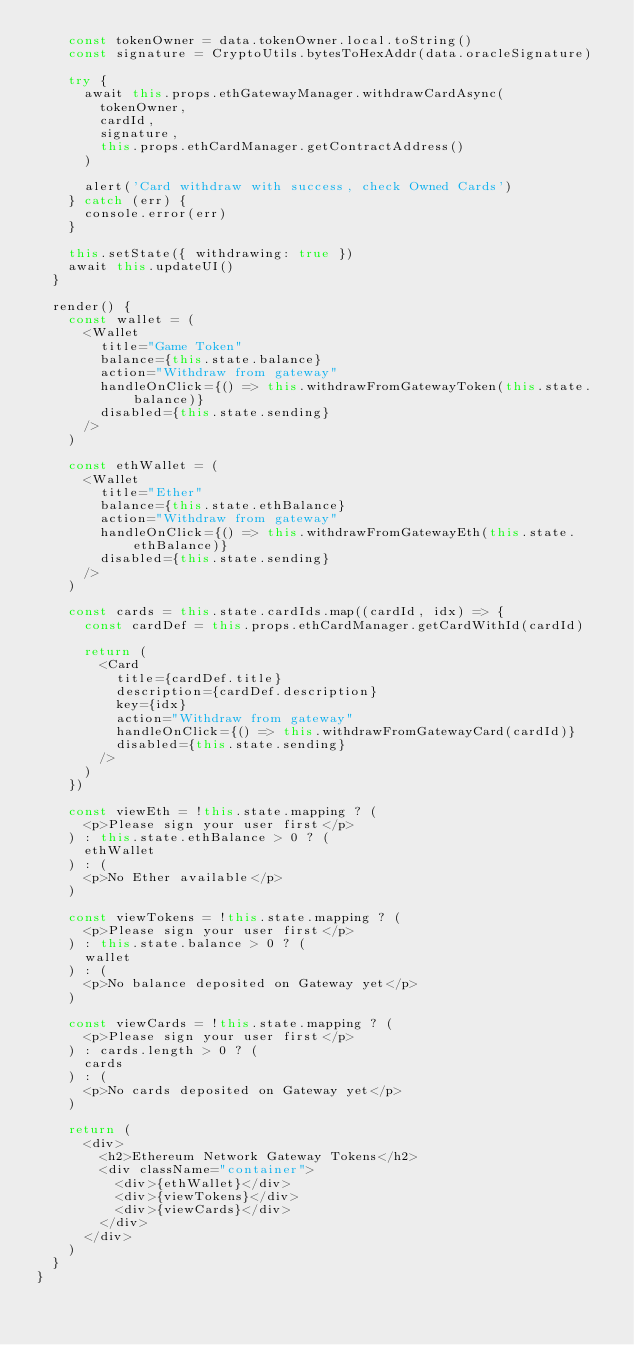Convert code to text. <code><loc_0><loc_0><loc_500><loc_500><_JavaScript_>    const tokenOwner = data.tokenOwner.local.toString()
    const signature = CryptoUtils.bytesToHexAddr(data.oracleSignature)

    try {
      await this.props.ethGatewayManager.withdrawCardAsync(
        tokenOwner,
        cardId,
        signature,
        this.props.ethCardManager.getContractAddress()
      )

      alert('Card withdraw with success, check Owned Cards')
    } catch (err) {
      console.error(err)
    }

    this.setState({ withdrawing: true })
    await this.updateUI()
  }

  render() {
    const wallet = (
      <Wallet
        title="Game Token"
        balance={this.state.balance}
        action="Withdraw from gateway"
        handleOnClick={() => this.withdrawFromGatewayToken(this.state.balance)}
        disabled={this.state.sending}
      />
    )

    const ethWallet = (
      <Wallet
        title="Ether"
        balance={this.state.ethBalance}
        action="Withdraw from gateway"
        handleOnClick={() => this.withdrawFromGatewayEth(this.state.ethBalance)}
        disabled={this.state.sending}
      />
    )

    const cards = this.state.cardIds.map((cardId, idx) => {
      const cardDef = this.props.ethCardManager.getCardWithId(cardId)

      return (
        <Card
          title={cardDef.title}
          description={cardDef.description}
          key={idx}
          action="Withdraw from gateway"
          handleOnClick={() => this.withdrawFromGatewayCard(cardId)}
          disabled={this.state.sending}
        />
      )
    })

    const viewEth = !this.state.mapping ? (
      <p>Please sign your user first</p>
    ) : this.state.ethBalance > 0 ? (
      ethWallet
    ) : (
      <p>No Ether available</p>
    )

    const viewTokens = !this.state.mapping ? (
      <p>Please sign your user first</p>
    ) : this.state.balance > 0 ? (
      wallet
    ) : (
      <p>No balance deposited on Gateway yet</p>
    )

    const viewCards = !this.state.mapping ? (
      <p>Please sign your user first</p>
    ) : cards.length > 0 ? (
      cards
    ) : (
      <p>No cards deposited on Gateway yet</p>
    )

    return (
      <div>
        <h2>Ethereum Network Gateway Tokens</h2>
        <div className="container">
          <div>{ethWallet}</div>
          <div>{viewTokens}</div>
          <div>{viewCards}</div>
        </div>
      </div>
    )
  }
}
</code> 